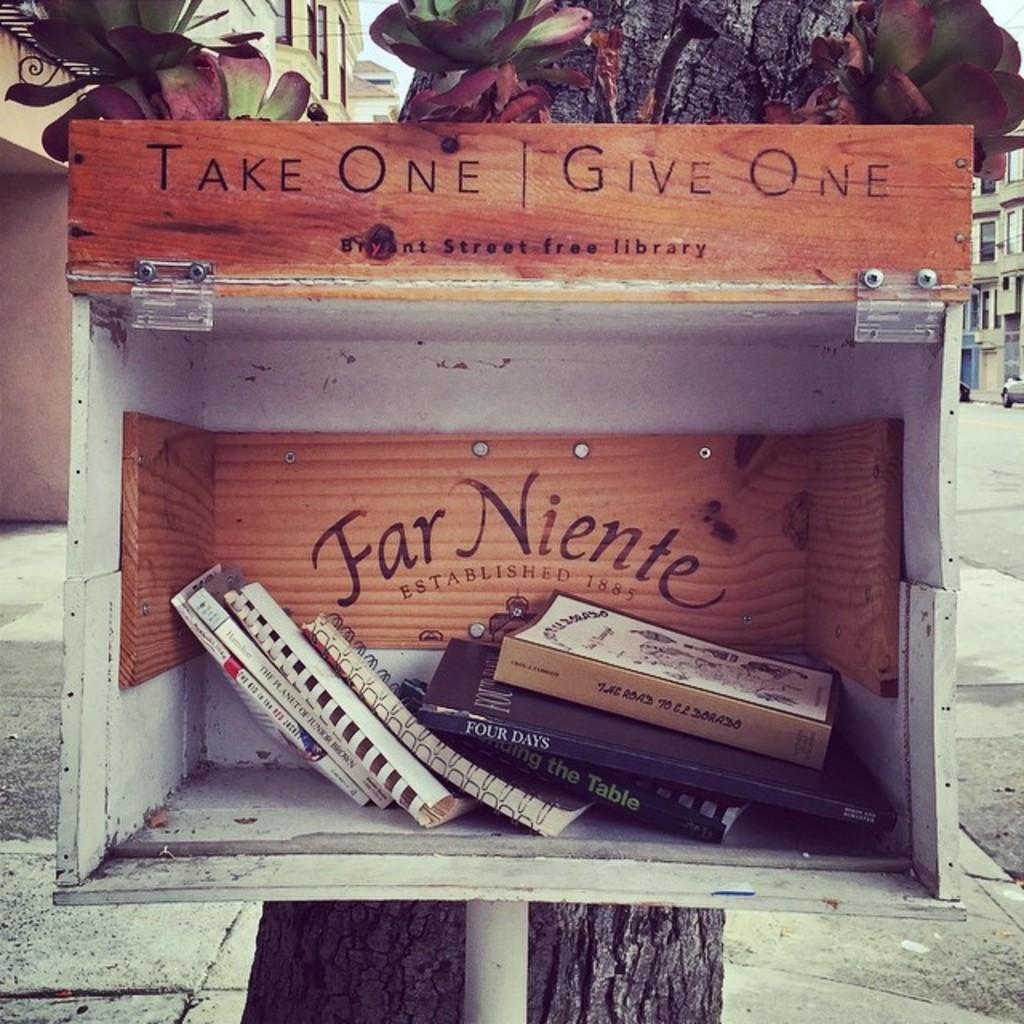<image>
Create a compact narrative representing the image presented. A case with books instructs "take one, give one." 